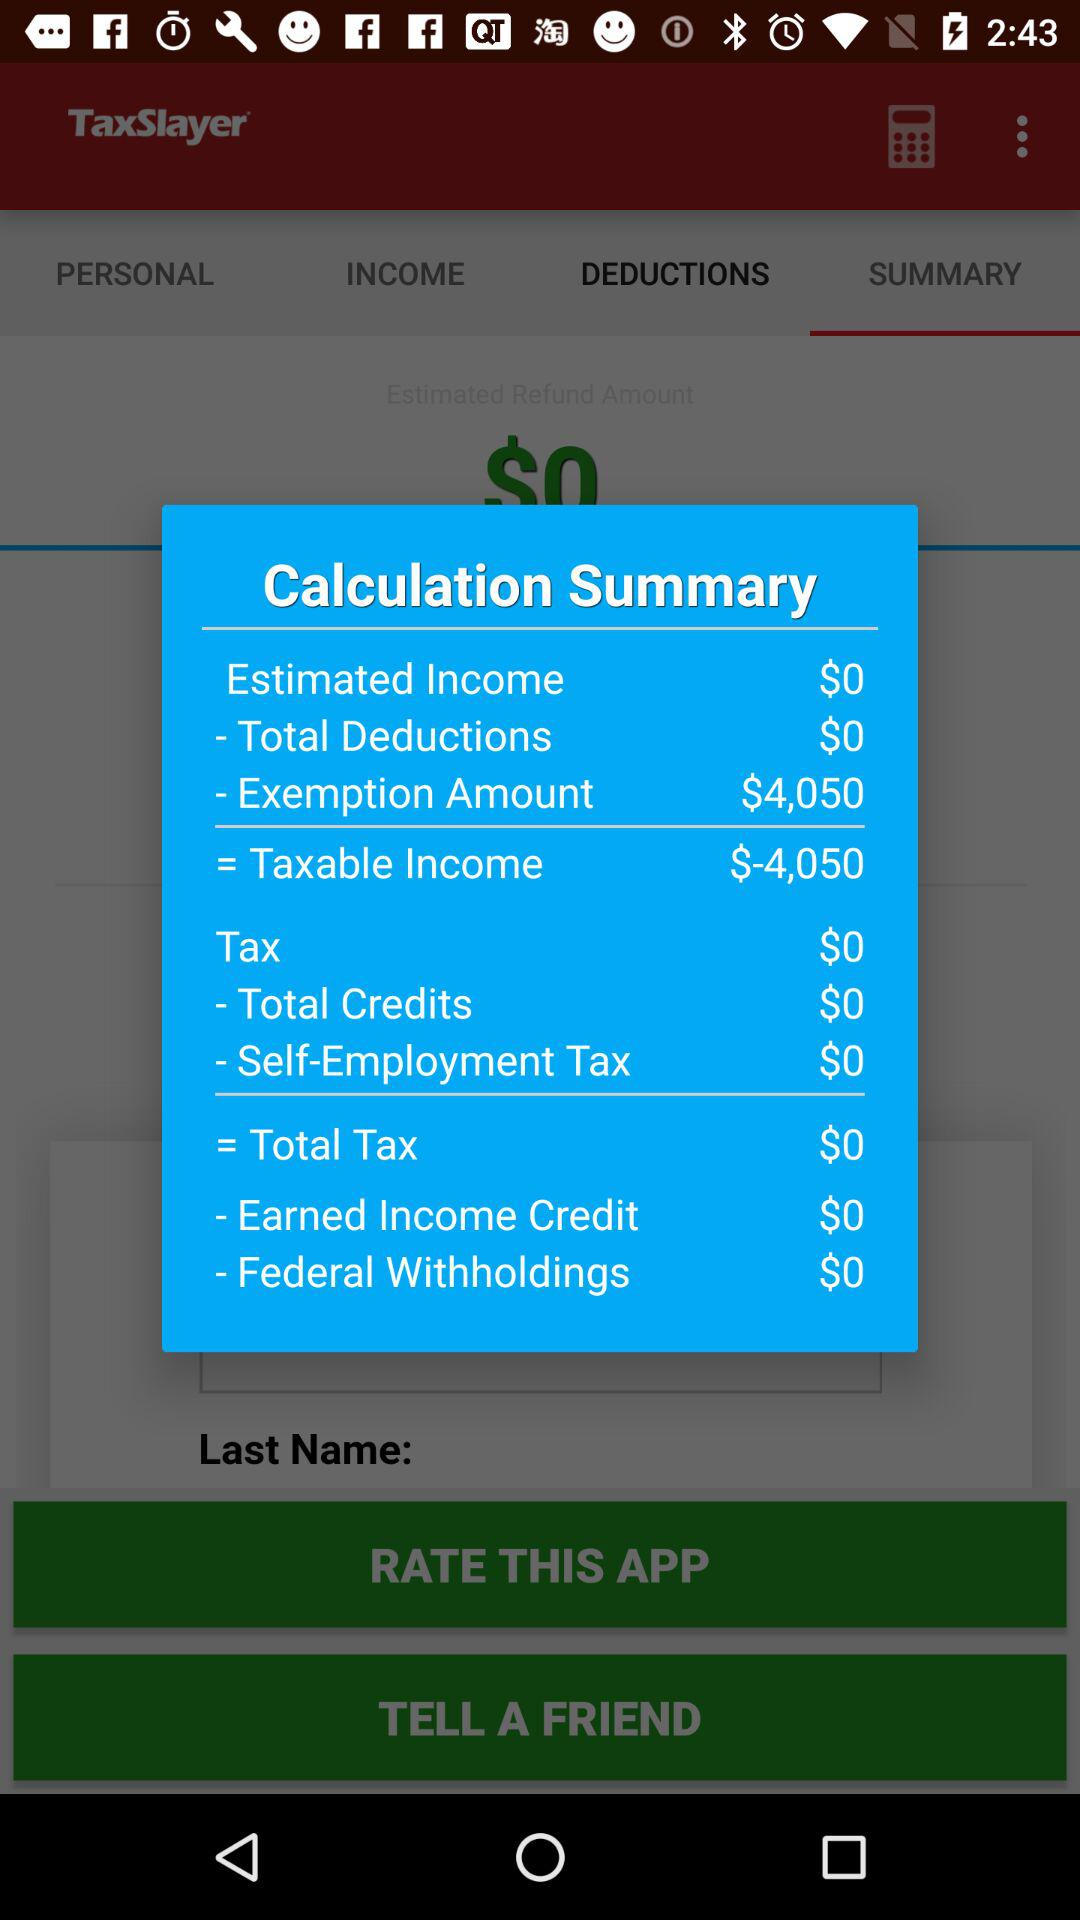What is the total amount of tax withheld?
Answer the question using a single word or phrase. $0 